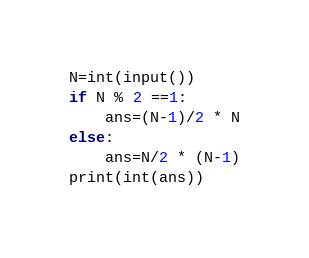<code> <loc_0><loc_0><loc_500><loc_500><_Python_>N=int(input())
if N % 2 ==1:
    ans=(N-1)/2 * N
else:
    ans=N/2 * (N-1)
print(int(ans))</code> 